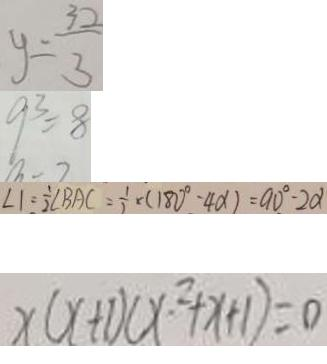Convert formula to latex. <formula><loc_0><loc_0><loc_500><loc_500>y = \frac { 3 2 } { 3 } 
 9 ^ { 3 } = 8 
 \angle 1 = \frac { 1 } { 2 } \angle B A C = \frac { 1 } { 2 } \times ( 1 8 0 ^ { \circ } - 4 \alpha ) = 9 0 ^ { \circ } - 2 \alpha 
 x ( x + 1 ) ( x ^ { 2 } + x + 1 ) = 0</formula> 